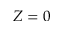Convert formula to latex. <formula><loc_0><loc_0><loc_500><loc_500>Z = 0</formula> 